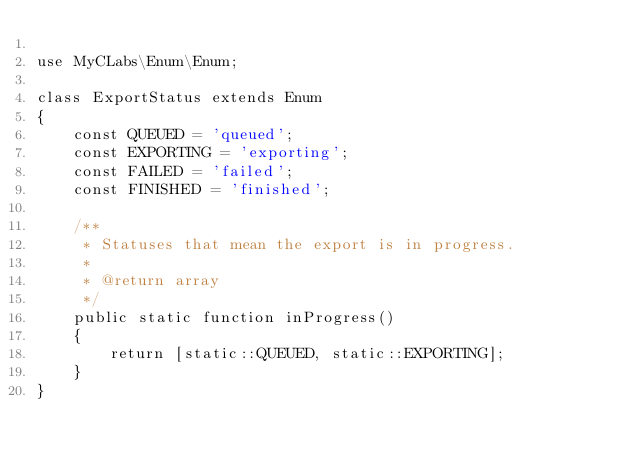Convert code to text. <code><loc_0><loc_0><loc_500><loc_500><_PHP_>
use MyCLabs\Enum\Enum;

class ExportStatus extends Enum
{
    const QUEUED = 'queued';
    const EXPORTING = 'exporting';
    const FAILED = 'failed';
    const FINISHED = 'finished';

    /**
     * Statuses that mean the export is in progress.
     *
     * @return array
     */
    public static function inProgress()
    {
        return [static::QUEUED, static::EXPORTING];
    }
}
</code> 